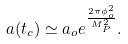<formula> <loc_0><loc_0><loc_500><loc_500>a ( t _ { c } ) \simeq a _ { o } e ^ { \frac { 2 \pi \phi _ { o } ^ { 2 } } { M _ { P } ^ { 2 } } } .</formula> 